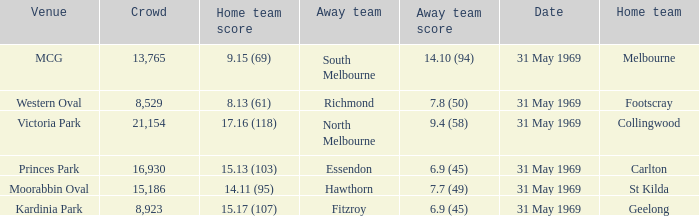Which home team scored 14.11 (95)? St Kilda. 